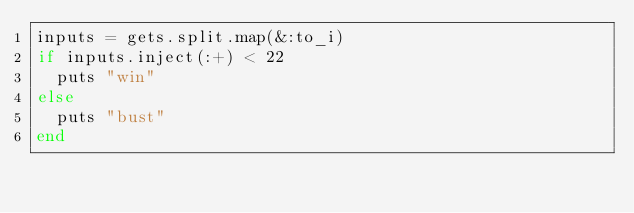<code> <loc_0><loc_0><loc_500><loc_500><_Ruby_>inputs = gets.split.map(&:to_i)
if inputs.inject(:+) < 22
  puts "win"
else
  puts "bust"
end
</code> 